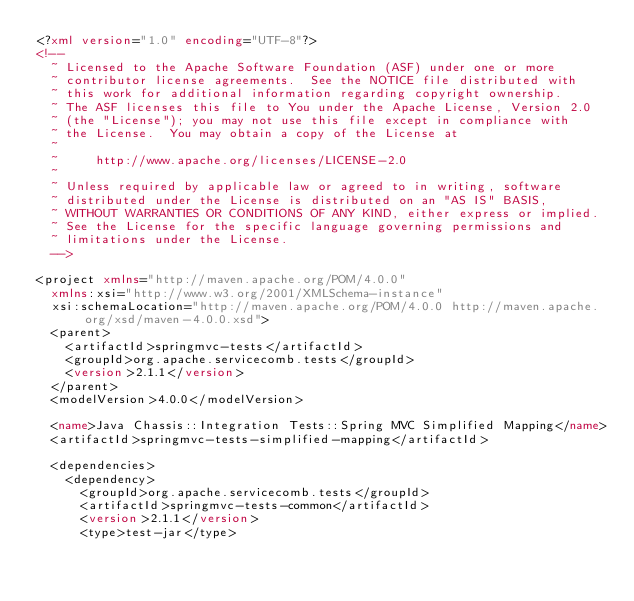<code> <loc_0><loc_0><loc_500><loc_500><_XML_><?xml version="1.0" encoding="UTF-8"?>
<!--
  ~ Licensed to the Apache Software Foundation (ASF) under one or more
  ~ contributor license agreements.  See the NOTICE file distributed with
  ~ this work for additional information regarding copyright ownership.
  ~ The ASF licenses this file to You under the Apache License, Version 2.0
  ~ (the "License"); you may not use this file except in compliance with
  ~ the License.  You may obtain a copy of the License at
  ~
  ~     http://www.apache.org/licenses/LICENSE-2.0
  ~
  ~ Unless required by applicable law or agreed to in writing, software
  ~ distributed under the License is distributed on an "AS IS" BASIS,
  ~ WITHOUT WARRANTIES OR CONDITIONS OF ANY KIND, either express or implied.
  ~ See the License for the specific language governing permissions and
  ~ limitations under the License.
  -->

<project xmlns="http://maven.apache.org/POM/4.0.0"
  xmlns:xsi="http://www.w3.org/2001/XMLSchema-instance"
  xsi:schemaLocation="http://maven.apache.org/POM/4.0.0 http://maven.apache.org/xsd/maven-4.0.0.xsd">
  <parent>
    <artifactId>springmvc-tests</artifactId>
    <groupId>org.apache.servicecomb.tests</groupId>
    <version>2.1.1</version>
  </parent>
  <modelVersion>4.0.0</modelVersion>

  <name>Java Chassis::Integration Tests::Spring MVC Simplified Mapping</name>
  <artifactId>springmvc-tests-simplified-mapping</artifactId>

  <dependencies>
    <dependency>
      <groupId>org.apache.servicecomb.tests</groupId>
      <artifactId>springmvc-tests-common</artifactId>
      <version>2.1.1</version>
      <type>test-jar</type></code> 